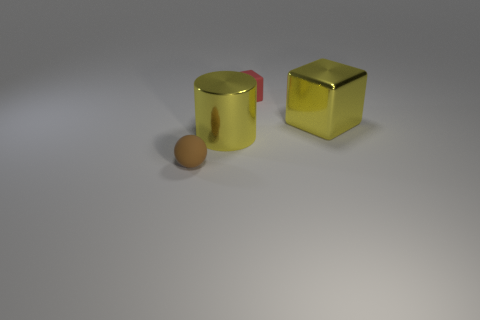What shape is the matte thing that is the same size as the red matte cube?
Ensure brevity in your answer.  Sphere. Is there a small rubber thing that has the same color as the large cube?
Your answer should be very brief. No. Are there the same number of large shiny objects behind the big metal cube and tiny rubber things?
Offer a very short reply. No. Do the large cube and the metal cylinder have the same color?
Give a very brief answer. Yes. There is a thing that is left of the large yellow metal block and right of the big yellow shiny cylinder; what is its size?
Provide a succinct answer. Small. The sphere that is made of the same material as the small red object is what color?
Keep it short and to the point. Brown. How many big objects are the same material as the tiny ball?
Your response must be concise. 0. Is the number of red blocks in front of the yellow block the same as the number of large yellow objects to the left of the brown sphere?
Provide a short and direct response. Yes. Do the brown matte thing and the matte thing to the right of the matte ball have the same shape?
Provide a succinct answer. No. What is the material of the large cylinder that is the same color as the large block?
Provide a short and direct response. Metal. 